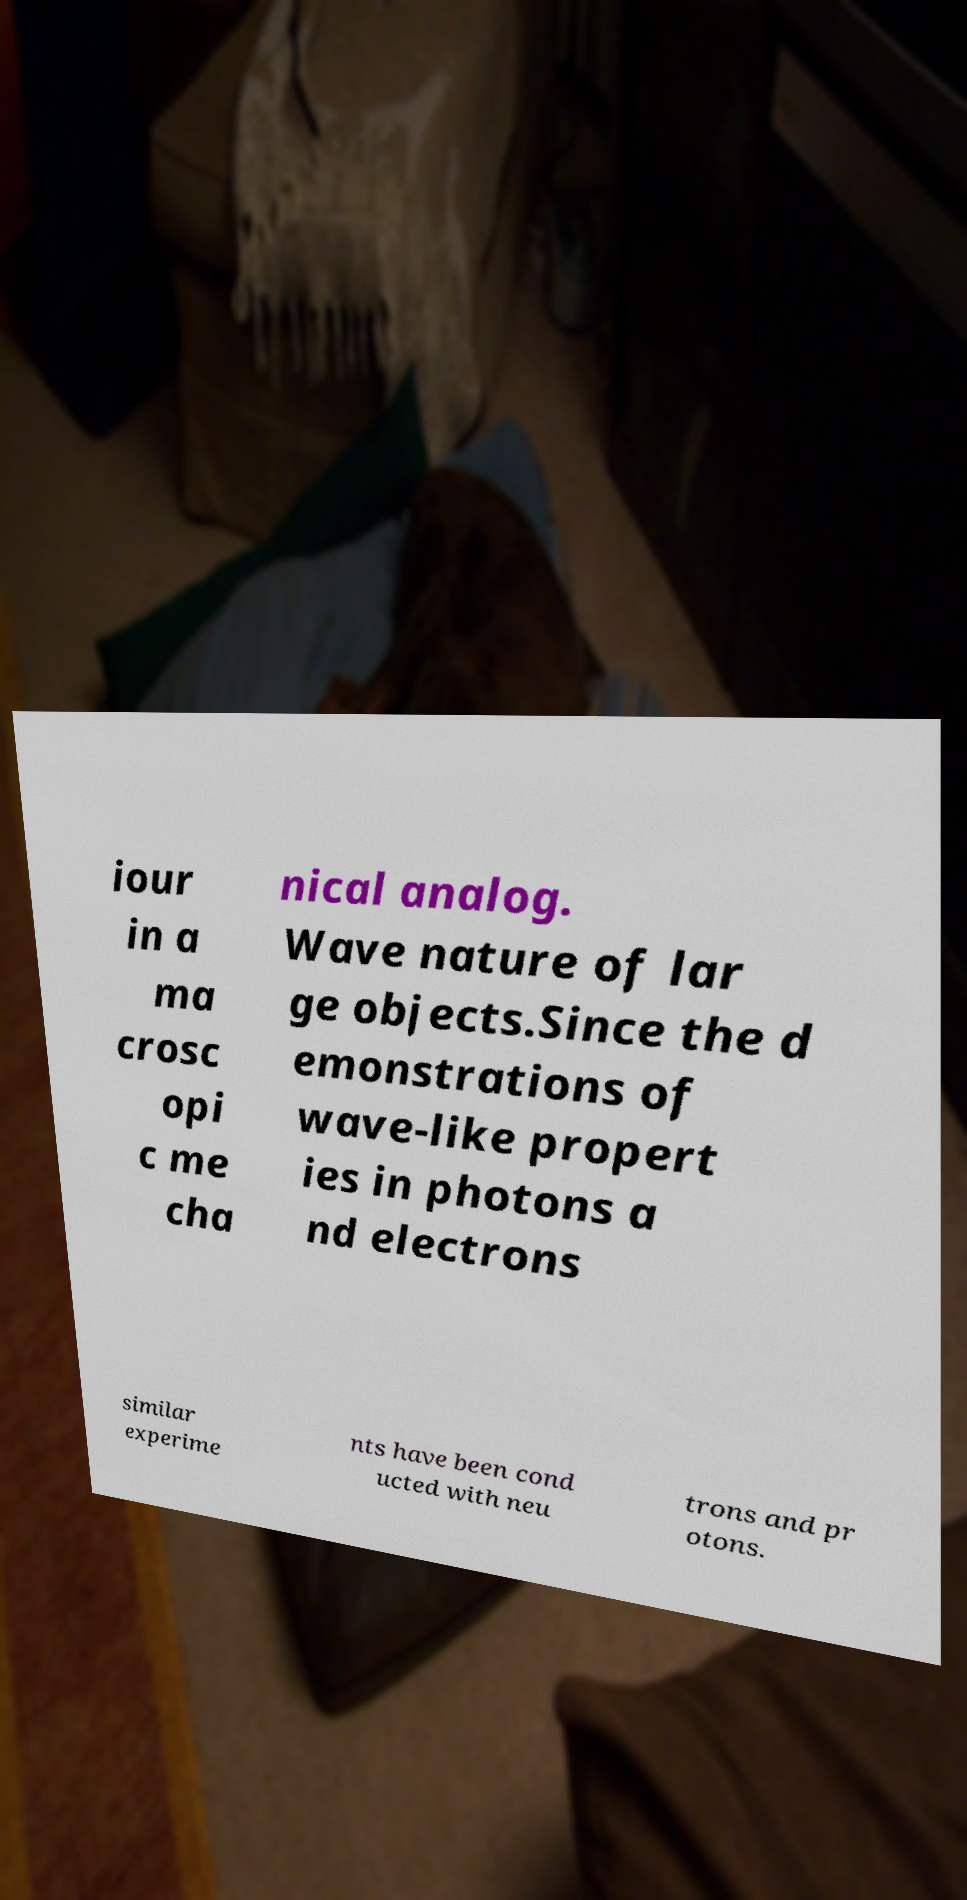I need the written content from this picture converted into text. Can you do that? iour in a ma crosc opi c me cha nical analog. Wave nature of lar ge objects.Since the d emonstrations of wave-like propert ies in photons a nd electrons similar experime nts have been cond ucted with neu trons and pr otons. 